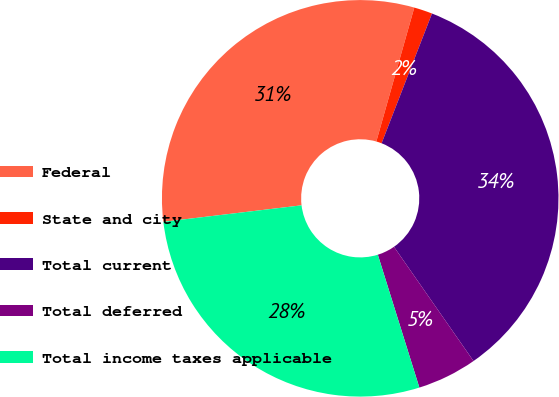Convert chart. <chart><loc_0><loc_0><loc_500><loc_500><pie_chart><fcel>Federal<fcel>State and city<fcel>Total current<fcel>Total deferred<fcel>Total income taxes applicable<nl><fcel>31.29%<fcel>1.5%<fcel>34.42%<fcel>4.86%<fcel>27.93%<nl></chart> 